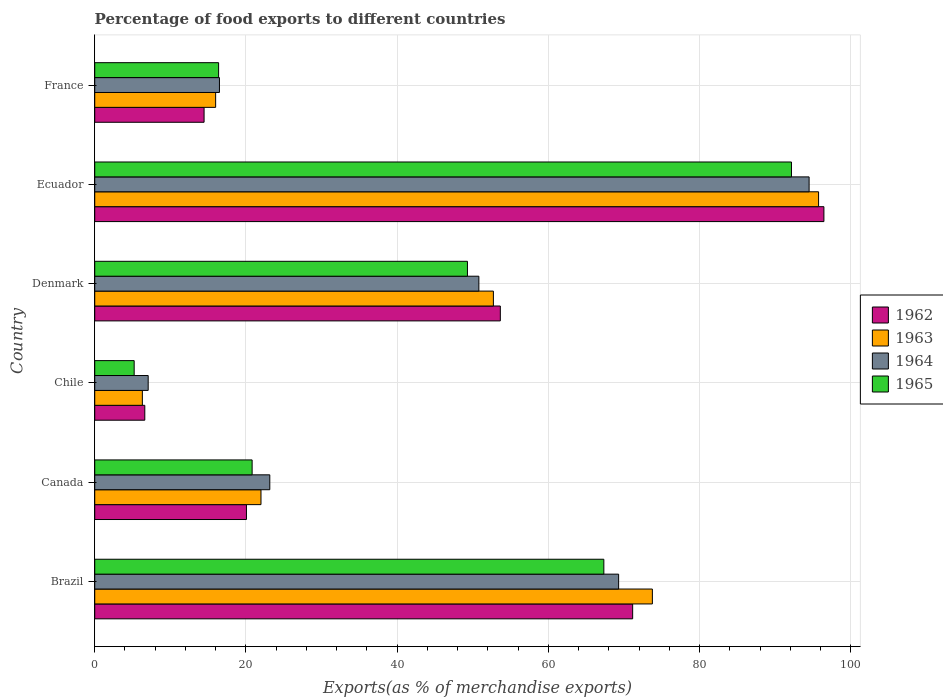How many different coloured bars are there?
Provide a short and direct response. 4. How many groups of bars are there?
Make the answer very short. 6. In how many cases, is the number of bars for a given country not equal to the number of legend labels?
Your answer should be very brief. 0. What is the percentage of exports to different countries in 1962 in Ecuador?
Ensure brevity in your answer.  96.45. Across all countries, what is the maximum percentage of exports to different countries in 1965?
Your answer should be compact. 92.15. Across all countries, what is the minimum percentage of exports to different countries in 1964?
Offer a terse response. 7.07. In which country was the percentage of exports to different countries in 1963 maximum?
Your response must be concise. Ecuador. In which country was the percentage of exports to different countries in 1965 minimum?
Offer a very short reply. Chile. What is the total percentage of exports to different countries in 1964 in the graph?
Provide a succinct answer. 261.31. What is the difference between the percentage of exports to different countries in 1962 in Canada and that in Denmark?
Provide a succinct answer. -33.58. What is the difference between the percentage of exports to different countries in 1965 in Brazil and the percentage of exports to different countries in 1963 in Denmark?
Provide a succinct answer. 14.61. What is the average percentage of exports to different countries in 1962 per country?
Provide a short and direct response. 43.73. What is the difference between the percentage of exports to different countries in 1965 and percentage of exports to different countries in 1964 in France?
Your response must be concise. -0.11. In how many countries, is the percentage of exports to different countries in 1965 greater than 36 %?
Make the answer very short. 3. What is the ratio of the percentage of exports to different countries in 1965 in Canada to that in Ecuador?
Ensure brevity in your answer.  0.23. Is the difference between the percentage of exports to different countries in 1965 in Chile and Denmark greater than the difference between the percentage of exports to different countries in 1964 in Chile and Denmark?
Provide a short and direct response. No. What is the difference between the highest and the second highest percentage of exports to different countries in 1962?
Offer a very short reply. 25.3. What is the difference between the highest and the lowest percentage of exports to different countries in 1965?
Your answer should be very brief. 86.94. In how many countries, is the percentage of exports to different countries in 1965 greater than the average percentage of exports to different countries in 1965 taken over all countries?
Your answer should be compact. 3. Is the sum of the percentage of exports to different countries in 1964 in Chile and France greater than the maximum percentage of exports to different countries in 1962 across all countries?
Keep it short and to the point. No. Is it the case that in every country, the sum of the percentage of exports to different countries in 1965 and percentage of exports to different countries in 1962 is greater than the sum of percentage of exports to different countries in 1964 and percentage of exports to different countries in 1963?
Your response must be concise. No. What does the 1st bar from the top in France represents?
Give a very brief answer. 1965. What does the 2nd bar from the bottom in Denmark represents?
Offer a terse response. 1963. Is it the case that in every country, the sum of the percentage of exports to different countries in 1963 and percentage of exports to different countries in 1964 is greater than the percentage of exports to different countries in 1965?
Give a very brief answer. Yes. How many bars are there?
Keep it short and to the point. 24. Are all the bars in the graph horizontal?
Offer a very short reply. Yes. How many countries are there in the graph?
Ensure brevity in your answer.  6. Are the values on the major ticks of X-axis written in scientific E-notation?
Ensure brevity in your answer.  No. Does the graph contain grids?
Keep it short and to the point. Yes. How many legend labels are there?
Your answer should be very brief. 4. What is the title of the graph?
Your answer should be compact. Percentage of food exports to different countries. What is the label or title of the X-axis?
Offer a terse response. Exports(as % of merchandise exports). What is the label or title of the Y-axis?
Keep it short and to the point. Country. What is the Exports(as % of merchandise exports) in 1962 in Brazil?
Provide a short and direct response. 71.15. What is the Exports(as % of merchandise exports) of 1963 in Brazil?
Give a very brief answer. 73.76. What is the Exports(as % of merchandise exports) in 1964 in Brazil?
Your answer should be compact. 69.29. What is the Exports(as % of merchandise exports) in 1965 in Brazil?
Ensure brevity in your answer.  67.34. What is the Exports(as % of merchandise exports) of 1962 in Canada?
Keep it short and to the point. 20.07. What is the Exports(as % of merchandise exports) of 1963 in Canada?
Keep it short and to the point. 21.99. What is the Exports(as % of merchandise exports) of 1964 in Canada?
Provide a short and direct response. 23.16. What is the Exports(as % of merchandise exports) in 1965 in Canada?
Your response must be concise. 20.82. What is the Exports(as % of merchandise exports) in 1962 in Chile?
Offer a very short reply. 6.62. What is the Exports(as % of merchandise exports) of 1963 in Chile?
Keep it short and to the point. 6.3. What is the Exports(as % of merchandise exports) in 1964 in Chile?
Your answer should be compact. 7.07. What is the Exports(as % of merchandise exports) in 1965 in Chile?
Your answer should be compact. 5.22. What is the Exports(as % of merchandise exports) in 1962 in Denmark?
Your answer should be very brief. 53.65. What is the Exports(as % of merchandise exports) in 1963 in Denmark?
Keep it short and to the point. 52.73. What is the Exports(as % of merchandise exports) of 1964 in Denmark?
Keep it short and to the point. 50.81. What is the Exports(as % of merchandise exports) in 1965 in Denmark?
Make the answer very short. 49.3. What is the Exports(as % of merchandise exports) of 1962 in Ecuador?
Keep it short and to the point. 96.45. What is the Exports(as % of merchandise exports) of 1963 in Ecuador?
Give a very brief answer. 95.74. What is the Exports(as % of merchandise exports) of 1964 in Ecuador?
Your answer should be very brief. 94.49. What is the Exports(as % of merchandise exports) in 1965 in Ecuador?
Keep it short and to the point. 92.15. What is the Exports(as % of merchandise exports) of 1962 in France?
Offer a very short reply. 14.46. What is the Exports(as % of merchandise exports) in 1963 in France?
Provide a succinct answer. 15.99. What is the Exports(as % of merchandise exports) in 1964 in France?
Your answer should be very brief. 16.5. What is the Exports(as % of merchandise exports) of 1965 in France?
Your answer should be compact. 16.38. Across all countries, what is the maximum Exports(as % of merchandise exports) of 1962?
Offer a terse response. 96.45. Across all countries, what is the maximum Exports(as % of merchandise exports) of 1963?
Provide a succinct answer. 95.74. Across all countries, what is the maximum Exports(as % of merchandise exports) of 1964?
Offer a terse response. 94.49. Across all countries, what is the maximum Exports(as % of merchandise exports) in 1965?
Give a very brief answer. 92.15. Across all countries, what is the minimum Exports(as % of merchandise exports) in 1962?
Provide a short and direct response. 6.62. Across all countries, what is the minimum Exports(as % of merchandise exports) of 1963?
Keep it short and to the point. 6.3. Across all countries, what is the minimum Exports(as % of merchandise exports) in 1964?
Your response must be concise. 7.07. Across all countries, what is the minimum Exports(as % of merchandise exports) in 1965?
Ensure brevity in your answer.  5.22. What is the total Exports(as % of merchandise exports) in 1962 in the graph?
Keep it short and to the point. 262.39. What is the total Exports(as % of merchandise exports) of 1963 in the graph?
Offer a very short reply. 266.51. What is the total Exports(as % of merchandise exports) of 1964 in the graph?
Your response must be concise. 261.31. What is the total Exports(as % of merchandise exports) in 1965 in the graph?
Make the answer very short. 251.21. What is the difference between the Exports(as % of merchandise exports) in 1962 in Brazil and that in Canada?
Your answer should be very brief. 51.08. What is the difference between the Exports(as % of merchandise exports) of 1963 in Brazil and that in Canada?
Ensure brevity in your answer.  51.77. What is the difference between the Exports(as % of merchandise exports) in 1964 in Brazil and that in Canada?
Your response must be concise. 46.14. What is the difference between the Exports(as % of merchandise exports) in 1965 in Brazil and that in Canada?
Offer a terse response. 46.52. What is the difference between the Exports(as % of merchandise exports) of 1962 in Brazil and that in Chile?
Make the answer very short. 64.53. What is the difference between the Exports(as % of merchandise exports) of 1963 in Brazil and that in Chile?
Make the answer very short. 67.46. What is the difference between the Exports(as % of merchandise exports) in 1964 in Brazil and that in Chile?
Give a very brief answer. 62.22. What is the difference between the Exports(as % of merchandise exports) of 1965 in Brazil and that in Chile?
Provide a succinct answer. 62.12. What is the difference between the Exports(as % of merchandise exports) in 1962 in Brazil and that in Denmark?
Your answer should be compact. 17.5. What is the difference between the Exports(as % of merchandise exports) in 1963 in Brazil and that in Denmark?
Offer a terse response. 21.03. What is the difference between the Exports(as % of merchandise exports) in 1964 in Brazil and that in Denmark?
Offer a terse response. 18.49. What is the difference between the Exports(as % of merchandise exports) in 1965 in Brazil and that in Denmark?
Your answer should be very brief. 18.04. What is the difference between the Exports(as % of merchandise exports) of 1962 in Brazil and that in Ecuador?
Provide a succinct answer. -25.3. What is the difference between the Exports(as % of merchandise exports) of 1963 in Brazil and that in Ecuador?
Your answer should be compact. -21.98. What is the difference between the Exports(as % of merchandise exports) in 1964 in Brazil and that in Ecuador?
Your response must be concise. -25.19. What is the difference between the Exports(as % of merchandise exports) in 1965 in Brazil and that in Ecuador?
Offer a very short reply. -24.82. What is the difference between the Exports(as % of merchandise exports) of 1962 in Brazil and that in France?
Offer a terse response. 56.69. What is the difference between the Exports(as % of merchandise exports) in 1963 in Brazil and that in France?
Provide a succinct answer. 57.76. What is the difference between the Exports(as % of merchandise exports) of 1964 in Brazil and that in France?
Your answer should be compact. 52.8. What is the difference between the Exports(as % of merchandise exports) in 1965 in Brazil and that in France?
Provide a short and direct response. 50.95. What is the difference between the Exports(as % of merchandise exports) of 1962 in Canada and that in Chile?
Offer a very short reply. 13.45. What is the difference between the Exports(as % of merchandise exports) in 1963 in Canada and that in Chile?
Give a very brief answer. 15.69. What is the difference between the Exports(as % of merchandise exports) of 1964 in Canada and that in Chile?
Your answer should be compact. 16.09. What is the difference between the Exports(as % of merchandise exports) of 1965 in Canada and that in Chile?
Give a very brief answer. 15.6. What is the difference between the Exports(as % of merchandise exports) in 1962 in Canada and that in Denmark?
Keep it short and to the point. -33.58. What is the difference between the Exports(as % of merchandise exports) in 1963 in Canada and that in Denmark?
Provide a succinct answer. -30.74. What is the difference between the Exports(as % of merchandise exports) in 1964 in Canada and that in Denmark?
Ensure brevity in your answer.  -27.65. What is the difference between the Exports(as % of merchandise exports) in 1965 in Canada and that in Denmark?
Provide a succinct answer. -28.48. What is the difference between the Exports(as % of merchandise exports) of 1962 in Canada and that in Ecuador?
Your response must be concise. -76.38. What is the difference between the Exports(as % of merchandise exports) in 1963 in Canada and that in Ecuador?
Offer a very short reply. -73.75. What is the difference between the Exports(as % of merchandise exports) in 1964 in Canada and that in Ecuador?
Give a very brief answer. -71.33. What is the difference between the Exports(as % of merchandise exports) of 1965 in Canada and that in Ecuador?
Offer a terse response. -71.34. What is the difference between the Exports(as % of merchandise exports) of 1962 in Canada and that in France?
Make the answer very short. 5.6. What is the difference between the Exports(as % of merchandise exports) in 1963 in Canada and that in France?
Make the answer very short. 6. What is the difference between the Exports(as % of merchandise exports) of 1964 in Canada and that in France?
Provide a succinct answer. 6.66. What is the difference between the Exports(as % of merchandise exports) of 1965 in Canada and that in France?
Provide a short and direct response. 4.43. What is the difference between the Exports(as % of merchandise exports) in 1962 in Chile and that in Denmark?
Provide a succinct answer. -47.02. What is the difference between the Exports(as % of merchandise exports) of 1963 in Chile and that in Denmark?
Offer a terse response. -46.43. What is the difference between the Exports(as % of merchandise exports) of 1964 in Chile and that in Denmark?
Offer a terse response. -43.74. What is the difference between the Exports(as % of merchandise exports) of 1965 in Chile and that in Denmark?
Offer a terse response. -44.08. What is the difference between the Exports(as % of merchandise exports) in 1962 in Chile and that in Ecuador?
Your answer should be compact. -89.82. What is the difference between the Exports(as % of merchandise exports) in 1963 in Chile and that in Ecuador?
Offer a terse response. -89.44. What is the difference between the Exports(as % of merchandise exports) of 1964 in Chile and that in Ecuador?
Make the answer very short. -87.42. What is the difference between the Exports(as % of merchandise exports) of 1965 in Chile and that in Ecuador?
Make the answer very short. -86.94. What is the difference between the Exports(as % of merchandise exports) in 1962 in Chile and that in France?
Your answer should be compact. -7.84. What is the difference between the Exports(as % of merchandise exports) of 1963 in Chile and that in France?
Make the answer very short. -9.69. What is the difference between the Exports(as % of merchandise exports) of 1964 in Chile and that in France?
Keep it short and to the point. -9.43. What is the difference between the Exports(as % of merchandise exports) in 1965 in Chile and that in France?
Your response must be concise. -11.17. What is the difference between the Exports(as % of merchandise exports) in 1962 in Denmark and that in Ecuador?
Ensure brevity in your answer.  -42.8. What is the difference between the Exports(as % of merchandise exports) in 1963 in Denmark and that in Ecuador?
Make the answer very short. -43.01. What is the difference between the Exports(as % of merchandise exports) in 1964 in Denmark and that in Ecuador?
Your answer should be compact. -43.68. What is the difference between the Exports(as % of merchandise exports) in 1965 in Denmark and that in Ecuador?
Give a very brief answer. -42.86. What is the difference between the Exports(as % of merchandise exports) in 1962 in Denmark and that in France?
Offer a terse response. 39.18. What is the difference between the Exports(as % of merchandise exports) in 1963 in Denmark and that in France?
Your response must be concise. 36.74. What is the difference between the Exports(as % of merchandise exports) in 1964 in Denmark and that in France?
Keep it short and to the point. 34.31. What is the difference between the Exports(as % of merchandise exports) of 1965 in Denmark and that in France?
Your answer should be compact. 32.91. What is the difference between the Exports(as % of merchandise exports) of 1962 in Ecuador and that in France?
Offer a very short reply. 81.98. What is the difference between the Exports(as % of merchandise exports) in 1963 in Ecuador and that in France?
Make the answer very short. 79.75. What is the difference between the Exports(as % of merchandise exports) of 1964 in Ecuador and that in France?
Your response must be concise. 77.99. What is the difference between the Exports(as % of merchandise exports) of 1965 in Ecuador and that in France?
Your response must be concise. 75.77. What is the difference between the Exports(as % of merchandise exports) of 1962 in Brazil and the Exports(as % of merchandise exports) of 1963 in Canada?
Your answer should be compact. 49.16. What is the difference between the Exports(as % of merchandise exports) of 1962 in Brazil and the Exports(as % of merchandise exports) of 1964 in Canada?
Keep it short and to the point. 47.99. What is the difference between the Exports(as % of merchandise exports) in 1962 in Brazil and the Exports(as % of merchandise exports) in 1965 in Canada?
Provide a short and direct response. 50.33. What is the difference between the Exports(as % of merchandise exports) of 1963 in Brazil and the Exports(as % of merchandise exports) of 1964 in Canada?
Make the answer very short. 50.6. What is the difference between the Exports(as % of merchandise exports) in 1963 in Brazil and the Exports(as % of merchandise exports) in 1965 in Canada?
Ensure brevity in your answer.  52.94. What is the difference between the Exports(as % of merchandise exports) of 1964 in Brazil and the Exports(as % of merchandise exports) of 1965 in Canada?
Your answer should be very brief. 48.48. What is the difference between the Exports(as % of merchandise exports) in 1962 in Brazil and the Exports(as % of merchandise exports) in 1963 in Chile?
Provide a succinct answer. 64.85. What is the difference between the Exports(as % of merchandise exports) in 1962 in Brazil and the Exports(as % of merchandise exports) in 1964 in Chile?
Make the answer very short. 64.08. What is the difference between the Exports(as % of merchandise exports) in 1962 in Brazil and the Exports(as % of merchandise exports) in 1965 in Chile?
Provide a succinct answer. 65.93. What is the difference between the Exports(as % of merchandise exports) of 1963 in Brazil and the Exports(as % of merchandise exports) of 1964 in Chile?
Offer a very short reply. 66.69. What is the difference between the Exports(as % of merchandise exports) of 1963 in Brazil and the Exports(as % of merchandise exports) of 1965 in Chile?
Your answer should be very brief. 68.54. What is the difference between the Exports(as % of merchandise exports) of 1964 in Brazil and the Exports(as % of merchandise exports) of 1965 in Chile?
Offer a terse response. 64.08. What is the difference between the Exports(as % of merchandise exports) in 1962 in Brazil and the Exports(as % of merchandise exports) in 1963 in Denmark?
Your response must be concise. 18.42. What is the difference between the Exports(as % of merchandise exports) of 1962 in Brazil and the Exports(as % of merchandise exports) of 1964 in Denmark?
Offer a terse response. 20.34. What is the difference between the Exports(as % of merchandise exports) in 1962 in Brazil and the Exports(as % of merchandise exports) in 1965 in Denmark?
Offer a terse response. 21.85. What is the difference between the Exports(as % of merchandise exports) in 1963 in Brazil and the Exports(as % of merchandise exports) in 1964 in Denmark?
Make the answer very short. 22.95. What is the difference between the Exports(as % of merchandise exports) of 1963 in Brazil and the Exports(as % of merchandise exports) of 1965 in Denmark?
Your answer should be compact. 24.46. What is the difference between the Exports(as % of merchandise exports) of 1964 in Brazil and the Exports(as % of merchandise exports) of 1965 in Denmark?
Your answer should be very brief. 20. What is the difference between the Exports(as % of merchandise exports) in 1962 in Brazil and the Exports(as % of merchandise exports) in 1963 in Ecuador?
Your answer should be very brief. -24.59. What is the difference between the Exports(as % of merchandise exports) of 1962 in Brazil and the Exports(as % of merchandise exports) of 1964 in Ecuador?
Ensure brevity in your answer.  -23.34. What is the difference between the Exports(as % of merchandise exports) of 1962 in Brazil and the Exports(as % of merchandise exports) of 1965 in Ecuador?
Your response must be concise. -21.01. What is the difference between the Exports(as % of merchandise exports) in 1963 in Brazil and the Exports(as % of merchandise exports) in 1964 in Ecuador?
Give a very brief answer. -20.73. What is the difference between the Exports(as % of merchandise exports) in 1963 in Brazil and the Exports(as % of merchandise exports) in 1965 in Ecuador?
Offer a terse response. -18.4. What is the difference between the Exports(as % of merchandise exports) in 1964 in Brazil and the Exports(as % of merchandise exports) in 1965 in Ecuador?
Ensure brevity in your answer.  -22.86. What is the difference between the Exports(as % of merchandise exports) of 1962 in Brazil and the Exports(as % of merchandise exports) of 1963 in France?
Offer a terse response. 55.16. What is the difference between the Exports(as % of merchandise exports) of 1962 in Brazil and the Exports(as % of merchandise exports) of 1964 in France?
Keep it short and to the point. 54.65. What is the difference between the Exports(as % of merchandise exports) in 1962 in Brazil and the Exports(as % of merchandise exports) in 1965 in France?
Your answer should be very brief. 54.77. What is the difference between the Exports(as % of merchandise exports) of 1963 in Brazil and the Exports(as % of merchandise exports) of 1964 in France?
Provide a short and direct response. 57.26. What is the difference between the Exports(as % of merchandise exports) of 1963 in Brazil and the Exports(as % of merchandise exports) of 1965 in France?
Ensure brevity in your answer.  57.37. What is the difference between the Exports(as % of merchandise exports) of 1964 in Brazil and the Exports(as % of merchandise exports) of 1965 in France?
Provide a short and direct response. 52.91. What is the difference between the Exports(as % of merchandise exports) in 1962 in Canada and the Exports(as % of merchandise exports) in 1963 in Chile?
Provide a succinct answer. 13.77. What is the difference between the Exports(as % of merchandise exports) in 1962 in Canada and the Exports(as % of merchandise exports) in 1964 in Chile?
Ensure brevity in your answer.  13. What is the difference between the Exports(as % of merchandise exports) in 1962 in Canada and the Exports(as % of merchandise exports) in 1965 in Chile?
Your answer should be very brief. 14.85. What is the difference between the Exports(as % of merchandise exports) of 1963 in Canada and the Exports(as % of merchandise exports) of 1964 in Chile?
Provide a short and direct response. 14.92. What is the difference between the Exports(as % of merchandise exports) in 1963 in Canada and the Exports(as % of merchandise exports) in 1965 in Chile?
Make the answer very short. 16.77. What is the difference between the Exports(as % of merchandise exports) of 1964 in Canada and the Exports(as % of merchandise exports) of 1965 in Chile?
Ensure brevity in your answer.  17.94. What is the difference between the Exports(as % of merchandise exports) of 1962 in Canada and the Exports(as % of merchandise exports) of 1963 in Denmark?
Keep it short and to the point. -32.66. What is the difference between the Exports(as % of merchandise exports) in 1962 in Canada and the Exports(as % of merchandise exports) in 1964 in Denmark?
Provide a short and direct response. -30.74. What is the difference between the Exports(as % of merchandise exports) in 1962 in Canada and the Exports(as % of merchandise exports) in 1965 in Denmark?
Make the answer very short. -29.23. What is the difference between the Exports(as % of merchandise exports) in 1963 in Canada and the Exports(as % of merchandise exports) in 1964 in Denmark?
Provide a succinct answer. -28.82. What is the difference between the Exports(as % of merchandise exports) in 1963 in Canada and the Exports(as % of merchandise exports) in 1965 in Denmark?
Your answer should be compact. -27.31. What is the difference between the Exports(as % of merchandise exports) in 1964 in Canada and the Exports(as % of merchandise exports) in 1965 in Denmark?
Provide a succinct answer. -26.14. What is the difference between the Exports(as % of merchandise exports) in 1962 in Canada and the Exports(as % of merchandise exports) in 1963 in Ecuador?
Your answer should be compact. -75.67. What is the difference between the Exports(as % of merchandise exports) in 1962 in Canada and the Exports(as % of merchandise exports) in 1964 in Ecuador?
Make the answer very short. -74.42. What is the difference between the Exports(as % of merchandise exports) in 1962 in Canada and the Exports(as % of merchandise exports) in 1965 in Ecuador?
Make the answer very short. -72.09. What is the difference between the Exports(as % of merchandise exports) in 1963 in Canada and the Exports(as % of merchandise exports) in 1964 in Ecuador?
Your response must be concise. -72.5. What is the difference between the Exports(as % of merchandise exports) in 1963 in Canada and the Exports(as % of merchandise exports) in 1965 in Ecuador?
Provide a succinct answer. -70.16. What is the difference between the Exports(as % of merchandise exports) in 1964 in Canada and the Exports(as % of merchandise exports) in 1965 in Ecuador?
Your answer should be compact. -69. What is the difference between the Exports(as % of merchandise exports) in 1962 in Canada and the Exports(as % of merchandise exports) in 1963 in France?
Keep it short and to the point. 4.07. What is the difference between the Exports(as % of merchandise exports) of 1962 in Canada and the Exports(as % of merchandise exports) of 1964 in France?
Give a very brief answer. 3.57. What is the difference between the Exports(as % of merchandise exports) of 1962 in Canada and the Exports(as % of merchandise exports) of 1965 in France?
Give a very brief answer. 3.68. What is the difference between the Exports(as % of merchandise exports) in 1963 in Canada and the Exports(as % of merchandise exports) in 1964 in France?
Make the answer very short. 5.49. What is the difference between the Exports(as % of merchandise exports) in 1963 in Canada and the Exports(as % of merchandise exports) in 1965 in France?
Make the answer very short. 5.61. What is the difference between the Exports(as % of merchandise exports) in 1964 in Canada and the Exports(as % of merchandise exports) in 1965 in France?
Your answer should be very brief. 6.77. What is the difference between the Exports(as % of merchandise exports) in 1962 in Chile and the Exports(as % of merchandise exports) in 1963 in Denmark?
Offer a very short reply. -46.11. What is the difference between the Exports(as % of merchandise exports) in 1962 in Chile and the Exports(as % of merchandise exports) in 1964 in Denmark?
Keep it short and to the point. -44.19. What is the difference between the Exports(as % of merchandise exports) of 1962 in Chile and the Exports(as % of merchandise exports) of 1965 in Denmark?
Your answer should be very brief. -42.68. What is the difference between the Exports(as % of merchandise exports) in 1963 in Chile and the Exports(as % of merchandise exports) in 1964 in Denmark?
Make the answer very short. -44.51. What is the difference between the Exports(as % of merchandise exports) in 1963 in Chile and the Exports(as % of merchandise exports) in 1965 in Denmark?
Give a very brief answer. -43. What is the difference between the Exports(as % of merchandise exports) in 1964 in Chile and the Exports(as % of merchandise exports) in 1965 in Denmark?
Keep it short and to the point. -42.23. What is the difference between the Exports(as % of merchandise exports) of 1962 in Chile and the Exports(as % of merchandise exports) of 1963 in Ecuador?
Your answer should be compact. -89.12. What is the difference between the Exports(as % of merchandise exports) of 1962 in Chile and the Exports(as % of merchandise exports) of 1964 in Ecuador?
Your answer should be very brief. -87.87. What is the difference between the Exports(as % of merchandise exports) in 1962 in Chile and the Exports(as % of merchandise exports) in 1965 in Ecuador?
Give a very brief answer. -85.53. What is the difference between the Exports(as % of merchandise exports) in 1963 in Chile and the Exports(as % of merchandise exports) in 1964 in Ecuador?
Provide a short and direct response. -88.19. What is the difference between the Exports(as % of merchandise exports) in 1963 in Chile and the Exports(as % of merchandise exports) in 1965 in Ecuador?
Provide a succinct answer. -85.86. What is the difference between the Exports(as % of merchandise exports) of 1964 in Chile and the Exports(as % of merchandise exports) of 1965 in Ecuador?
Offer a very short reply. -85.08. What is the difference between the Exports(as % of merchandise exports) of 1962 in Chile and the Exports(as % of merchandise exports) of 1963 in France?
Your response must be concise. -9.37. What is the difference between the Exports(as % of merchandise exports) in 1962 in Chile and the Exports(as % of merchandise exports) in 1964 in France?
Offer a very short reply. -9.87. What is the difference between the Exports(as % of merchandise exports) of 1962 in Chile and the Exports(as % of merchandise exports) of 1965 in France?
Give a very brief answer. -9.76. What is the difference between the Exports(as % of merchandise exports) in 1963 in Chile and the Exports(as % of merchandise exports) in 1964 in France?
Make the answer very short. -10.2. What is the difference between the Exports(as % of merchandise exports) of 1963 in Chile and the Exports(as % of merchandise exports) of 1965 in France?
Keep it short and to the point. -10.09. What is the difference between the Exports(as % of merchandise exports) in 1964 in Chile and the Exports(as % of merchandise exports) in 1965 in France?
Your response must be concise. -9.31. What is the difference between the Exports(as % of merchandise exports) of 1962 in Denmark and the Exports(as % of merchandise exports) of 1963 in Ecuador?
Your answer should be compact. -42.09. What is the difference between the Exports(as % of merchandise exports) in 1962 in Denmark and the Exports(as % of merchandise exports) in 1964 in Ecuador?
Make the answer very short. -40.84. What is the difference between the Exports(as % of merchandise exports) of 1962 in Denmark and the Exports(as % of merchandise exports) of 1965 in Ecuador?
Your response must be concise. -38.51. What is the difference between the Exports(as % of merchandise exports) in 1963 in Denmark and the Exports(as % of merchandise exports) in 1964 in Ecuador?
Keep it short and to the point. -41.76. What is the difference between the Exports(as % of merchandise exports) in 1963 in Denmark and the Exports(as % of merchandise exports) in 1965 in Ecuador?
Give a very brief answer. -39.43. What is the difference between the Exports(as % of merchandise exports) of 1964 in Denmark and the Exports(as % of merchandise exports) of 1965 in Ecuador?
Offer a terse response. -41.35. What is the difference between the Exports(as % of merchandise exports) in 1962 in Denmark and the Exports(as % of merchandise exports) in 1963 in France?
Ensure brevity in your answer.  37.65. What is the difference between the Exports(as % of merchandise exports) of 1962 in Denmark and the Exports(as % of merchandise exports) of 1964 in France?
Make the answer very short. 37.15. What is the difference between the Exports(as % of merchandise exports) of 1962 in Denmark and the Exports(as % of merchandise exports) of 1965 in France?
Keep it short and to the point. 37.26. What is the difference between the Exports(as % of merchandise exports) of 1963 in Denmark and the Exports(as % of merchandise exports) of 1964 in France?
Your answer should be compact. 36.23. What is the difference between the Exports(as % of merchandise exports) of 1963 in Denmark and the Exports(as % of merchandise exports) of 1965 in France?
Make the answer very short. 36.34. What is the difference between the Exports(as % of merchandise exports) of 1964 in Denmark and the Exports(as % of merchandise exports) of 1965 in France?
Offer a terse response. 34.42. What is the difference between the Exports(as % of merchandise exports) of 1962 in Ecuador and the Exports(as % of merchandise exports) of 1963 in France?
Your answer should be very brief. 80.45. What is the difference between the Exports(as % of merchandise exports) of 1962 in Ecuador and the Exports(as % of merchandise exports) of 1964 in France?
Your answer should be very brief. 79.95. What is the difference between the Exports(as % of merchandise exports) of 1962 in Ecuador and the Exports(as % of merchandise exports) of 1965 in France?
Your answer should be compact. 80.06. What is the difference between the Exports(as % of merchandise exports) of 1963 in Ecuador and the Exports(as % of merchandise exports) of 1964 in France?
Keep it short and to the point. 79.24. What is the difference between the Exports(as % of merchandise exports) of 1963 in Ecuador and the Exports(as % of merchandise exports) of 1965 in France?
Offer a very short reply. 79.36. What is the difference between the Exports(as % of merchandise exports) in 1964 in Ecuador and the Exports(as % of merchandise exports) in 1965 in France?
Your response must be concise. 78.1. What is the average Exports(as % of merchandise exports) in 1962 per country?
Your answer should be very brief. 43.73. What is the average Exports(as % of merchandise exports) of 1963 per country?
Ensure brevity in your answer.  44.42. What is the average Exports(as % of merchandise exports) in 1964 per country?
Ensure brevity in your answer.  43.55. What is the average Exports(as % of merchandise exports) in 1965 per country?
Give a very brief answer. 41.87. What is the difference between the Exports(as % of merchandise exports) of 1962 and Exports(as % of merchandise exports) of 1963 in Brazil?
Provide a succinct answer. -2.61. What is the difference between the Exports(as % of merchandise exports) of 1962 and Exports(as % of merchandise exports) of 1964 in Brazil?
Provide a short and direct response. 1.86. What is the difference between the Exports(as % of merchandise exports) in 1962 and Exports(as % of merchandise exports) in 1965 in Brazil?
Offer a very short reply. 3.81. What is the difference between the Exports(as % of merchandise exports) of 1963 and Exports(as % of merchandise exports) of 1964 in Brazil?
Your answer should be very brief. 4.46. What is the difference between the Exports(as % of merchandise exports) in 1963 and Exports(as % of merchandise exports) in 1965 in Brazil?
Make the answer very short. 6.42. What is the difference between the Exports(as % of merchandise exports) of 1964 and Exports(as % of merchandise exports) of 1965 in Brazil?
Provide a succinct answer. 1.96. What is the difference between the Exports(as % of merchandise exports) in 1962 and Exports(as % of merchandise exports) in 1963 in Canada?
Ensure brevity in your answer.  -1.92. What is the difference between the Exports(as % of merchandise exports) of 1962 and Exports(as % of merchandise exports) of 1964 in Canada?
Give a very brief answer. -3.09. What is the difference between the Exports(as % of merchandise exports) of 1962 and Exports(as % of merchandise exports) of 1965 in Canada?
Provide a succinct answer. -0.75. What is the difference between the Exports(as % of merchandise exports) in 1963 and Exports(as % of merchandise exports) in 1964 in Canada?
Make the answer very short. -1.17. What is the difference between the Exports(as % of merchandise exports) of 1963 and Exports(as % of merchandise exports) of 1965 in Canada?
Your answer should be compact. 1.17. What is the difference between the Exports(as % of merchandise exports) of 1964 and Exports(as % of merchandise exports) of 1965 in Canada?
Keep it short and to the point. 2.34. What is the difference between the Exports(as % of merchandise exports) in 1962 and Exports(as % of merchandise exports) in 1963 in Chile?
Ensure brevity in your answer.  0.32. What is the difference between the Exports(as % of merchandise exports) in 1962 and Exports(as % of merchandise exports) in 1964 in Chile?
Provide a succinct answer. -0.45. What is the difference between the Exports(as % of merchandise exports) of 1962 and Exports(as % of merchandise exports) of 1965 in Chile?
Give a very brief answer. 1.4. What is the difference between the Exports(as % of merchandise exports) of 1963 and Exports(as % of merchandise exports) of 1964 in Chile?
Your answer should be compact. -0.77. What is the difference between the Exports(as % of merchandise exports) of 1963 and Exports(as % of merchandise exports) of 1965 in Chile?
Ensure brevity in your answer.  1.08. What is the difference between the Exports(as % of merchandise exports) of 1964 and Exports(as % of merchandise exports) of 1965 in Chile?
Provide a succinct answer. 1.85. What is the difference between the Exports(as % of merchandise exports) of 1962 and Exports(as % of merchandise exports) of 1963 in Denmark?
Keep it short and to the point. 0.92. What is the difference between the Exports(as % of merchandise exports) of 1962 and Exports(as % of merchandise exports) of 1964 in Denmark?
Give a very brief answer. 2.84. What is the difference between the Exports(as % of merchandise exports) in 1962 and Exports(as % of merchandise exports) in 1965 in Denmark?
Offer a very short reply. 4.35. What is the difference between the Exports(as % of merchandise exports) in 1963 and Exports(as % of merchandise exports) in 1964 in Denmark?
Provide a short and direct response. 1.92. What is the difference between the Exports(as % of merchandise exports) of 1963 and Exports(as % of merchandise exports) of 1965 in Denmark?
Your answer should be very brief. 3.43. What is the difference between the Exports(as % of merchandise exports) of 1964 and Exports(as % of merchandise exports) of 1965 in Denmark?
Your answer should be very brief. 1.51. What is the difference between the Exports(as % of merchandise exports) in 1962 and Exports(as % of merchandise exports) in 1963 in Ecuador?
Ensure brevity in your answer.  0.71. What is the difference between the Exports(as % of merchandise exports) of 1962 and Exports(as % of merchandise exports) of 1964 in Ecuador?
Offer a terse response. 1.96. What is the difference between the Exports(as % of merchandise exports) in 1962 and Exports(as % of merchandise exports) in 1965 in Ecuador?
Offer a very short reply. 4.29. What is the difference between the Exports(as % of merchandise exports) of 1963 and Exports(as % of merchandise exports) of 1964 in Ecuador?
Your answer should be very brief. 1.25. What is the difference between the Exports(as % of merchandise exports) in 1963 and Exports(as % of merchandise exports) in 1965 in Ecuador?
Ensure brevity in your answer.  3.58. What is the difference between the Exports(as % of merchandise exports) of 1964 and Exports(as % of merchandise exports) of 1965 in Ecuador?
Ensure brevity in your answer.  2.33. What is the difference between the Exports(as % of merchandise exports) in 1962 and Exports(as % of merchandise exports) in 1963 in France?
Ensure brevity in your answer.  -1.53. What is the difference between the Exports(as % of merchandise exports) in 1962 and Exports(as % of merchandise exports) in 1964 in France?
Keep it short and to the point. -2.03. What is the difference between the Exports(as % of merchandise exports) of 1962 and Exports(as % of merchandise exports) of 1965 in France?
Give a very brief answer. -1.92. What is the difference between the Exports(as % of merchandise exports) of 1963 and Exports(as % of merchandise exports) of 1964 in France?
Provide a short and direct response. -0.5. What is the difference between the Exports(as % of merchandise exports) of 1963 and Exports(as % of merchandise exports) of 1965 in France?
Keep it short and to the point. -0.39. What is the difference between the Exports(as % of merchandise exports) in 1964 and Exports(as % of merchandise exports) in 1965 in France?
Ensure brevity in your answer.  0.11. What is the ratio of the Exports(as % of merchandise exports) of 1962 in Brazil to that in Canada?
Provide a short and direct response. 3.55. What is the ratio of the Exports(as % of merchandise exports) in 1963 in Brazil to that in Canada?
Your answer should be compact. 3.35. What is the ratio of the Exports(as % of merchandise exports) in 1964 in Brazil to that in Canada?
Make the answer very short. 2.99. What is the ratio of the Exports(as % of merchandise exports) of 1965 in Brazil to that in Canada?
Your answer should be very brief. 3.23. What is the ratio of the Exports(as % of merchandise exports) in 1962 in Brazil to that in Chile?
Give a very brief answer. 10.75. What is the ratio of the Exports(as % of merchandise exports) in 1963 in Brazil to that in Chile?
Provide a succinct answer. 11.71. What is the ratio of the Exports(as % of merchandise exports) in 1964 in Brazil to that in Chile?
Your answer should be very brief. 9.8. What is the ratio of the Exports(as % of merchandise exports) in 1965 in Brazil to that in Chile?
Offer a very short reply. 12.91. What is the ratio of the Exports(as % of merchandise exports) in 1962 in Brazil to that in Denmark?
Offer a very short reply. 1.33. What is the ratio of the Exports(as % of merchandise exports) of 1963 in Brazil to that in Denmark?
Your response must be concise. 1.4. What is the ratio of the Exports(as % of merchandise exports) in 1964 in Brazil to that in Denmark?
Your answer should be very brief. 1.36. What is the ratio of the Exports(as % of merchandise exports) of 1965 in Brazil to that in Denmark?
Your answer should be compact. 1.37. What is the ratio of the Exports(as % of merchandise exports) in 1962 in Brazil to that in Ecuador?
Provide a succinct answer. 0.74. What is the ratio of the Exports(as % of merchandise exports) in 1963 in Brazil to that in Ecuador?
Make the answer very short. 0.77. What is the ratio of the Exports(as % of merchandise exports) of 1964 in Brazil to that in Ecuador?
Give a very brief answer. 0.73. What is the ratio of the Exports(as % of merchandise exports) of 1965 in Brazil to that in Ecuador?
Provide a succinct answer. 0.73. What is the ratio of the Exports(as % of merchandise exports) of 1962 in Brazil to that in France?
Your response must be concise. 4.92. What is the ratio of the Exports(as % of merchandise exports) in 1963 in Brazil to that in France?
Ensure brevity in your answer.  4.61. What is the ratio of the Exports(as % of merchandise exports) of 1964 in Brazil to that in France?
Offer a terse response. 4.2. What is the ratio of the Exports(as % of merchandise exports) of 1965 in Brazil to that in France?
Provide a short and direct response. 4.11. What is the ratio of the Exports(as % of merchandise exports) in 1962 in Canada to that in Chile?
Provide a succinct answer. 3.03. What is the ratio of the Exports(as % of merchandise exports) of 1963 in Canada to that in Chile?
Provide a short and direct response. 3.49. What is the ratio of the Exports(as % of merchandise exports) of 1964 in Canada to that in Chile?
Keep it short and to the point. 3.28. What is the ratio of the Exports(as % of merchandise exports) in 1965 in Canada to that in Chile?
Offer a very short reply. 3.99. What is the ratio of the Exports(as % of merchandise exports) in 1962 in Canada to that in Denmark?
Your response must be concise. 0.37. What is the ratio of the Exports(as % of merchandise exports) of 1963 in Canada to that in Denmark?
Offer a very short reply. 0.42. What is the ratio of the Exports(as % of merchandise exports) in 1964 in Canada to that in Denmark?
Offer a very short reply. 0.46. What is the ratio of the Exports(as % of merchandise exports) in 1965 in Canada to that in Denmark?
Ensure brevity in your answer.  0.42. What is the ratio of the Exports(as % of merchandise exports) of 1962 in Canada to that in Ecuador?
Provide a short and direct response. 0.21. What is the ratio of the Exports(as % of merchandise exports) of 1963 in Canada to that in Ecuador?
Ensure brevity in your answer.  0.23. What is the ratio of the Exports(as % of merchandise exports) in 1964 in Canada to that in Ecuador?
Your response must be concise. 0.25. What is the ratio of the Exports(as % of merchandise exports) in 1965 in Canada to that in Ecuador?
Make the answer very short. 0.23. What is the ratio of the Exports(as % of merchandise exports) in 1962 in Canada to that in France?
Your answer should be very brief. 1.39. What is the ratio of the Exports(as % of merchandise exports) in 1963 in Canada to that in France?
Make the answer very short. 1.38. What is the ratio of the Exports(as % of merchandise exports) in 1964 in Canada to that in France?
Your response must be concise. 1.4. What is the ratio of the Exports(as % of merchandise exports) of 1965 in Canada to that in France?
Give a very brief answer. 1.27. What is the ratio of the Exports(as % of merchandise exports) in 1962 in Chile to that in Denmark?
Your answer should be compact. 0.12. What is the ratio of the Exports(as % of merchandise exports) of 1963 in Chile to that in Denmark?
Keep it short and to the point. 0.12. What is the ratio of the Exports(as % of merchandise exports) in 1964 in Chile to that in Denmark?
Give a very brief answer. 0.14. What is the ratio of the Exports(as % of merchandise exports) in 1965 in Chile to that in Denmark?
Provide a succinct answer. 0.11. What is the ratio of the Exports(as % of merchandise exports) in 1962 in Chile to that in Ecuador?
Keep it short and to the point. 0.07. What is the ratio of the Exports(as % of merchandise exports) in 1963 in Chile to that in Ecuador?
Offer a very short reply. 0.07. What is the ratio of the Exports(as % of merchandise exports) of 1964 in Chile to that in Ecuador?
Give a very brief answer. 0.07. What is the ratio of the Exports(as % of merchandise exports) of 1965 in Chile to that in Ecuador?
Your response must be concise. 0.06. What is the ratio of the Exports(as % of merchandise exports) in 1962 in Chile to that in France?
Give a very brief answer. 0.46. What is the ratio of the Exports(as % of merchandise exports) in 1963 in Chile to that in France?
Ensure brevity in your answer.  0.39. What is the ratio of the Exports(as % of merchandise exports) in 1964 in Chile to that in France?
Offer a very short reply. 0.43. What is the ratio of the Exports(as % of merchandise exports) of 1965 in Chile to that in France?
Keep it short and to the point. 0.32. What is the ratio of the Exports(as % of merchandise exports) in 1962 in Denmark to that in Ecuador?
Provide a short and direct response. 0.56. What is the ratio of the Exports(as % of merchandise exports) of 1963 in Denmark to that in Ecuador?
Offer a terse response. 0.55. What is the ratio of the Exports(as % of merchandise exports) of 1964 in Denmark to that in Ecuador?
Provide a short and direct response. 0.54. What is the ratio of the Exports(as % of merchandise exports) in 1965 in Denmark to that in Ecuador?
Make the answer very short. 0.53. What is the ratio of the Exports(as % of merchandise exports) of 1962 in Denmark to that in France?
Provide a short and direct response. 3.71. What is the ratio of the Exports(as % of merchandise exports) of 1963 in Denmark to that in France?
Keep it short and to the point. 3.3. What is the ratio of the Exports(as % of merchandise exports) of 1964 in Denmark to that in France?
Make the answer very short. 3.08. What is the ratio of the Exports(as % of merchandise exports) of 1965 in Denmark to that in France?
Give a very brief answer. 3.01. What is the ratio of the Exports(as % of merchandise exports) of 1962 in Ecuador to that in France?
Your answer should be compact. 6.67. What is the ratio of the Exports(as % of merchandise exports) in 1963 in Ecuador to that in France?
Make the answer very short. 5.99. What is the ratio of the Exports(as % of merchandise exports) of 1964 in Ecuador to that in France?
Your response must be concise. 5.73. What is the ratio of the Exports(as % of merchandise exports) in 1965 in Ecuador to that in France?
Your answer should be very brief. 5.62. What is the difference between the highest and the second highest Exports(as % of merchandise exports) of 1962?
Offer a very short reply. 25.3. What is the difference between the highest and the second highest Exports(as % of merchandise exports) of 1963?
Your response must be concise. 21.98. What is the difference between the highest and the second highest Exports(as % of merchandise exports) in 1964?
Your answer should be compact. 25.19. What is the difference between the highest and the second highest Exports(as % of merchandise exports) in 1965?
Your answer should be compact. 24.82. What is the difference between the highest and the lowest Exports(as % of merchandise exports) in 1962?
Your answer should be very brief. 89.82. What is the difference between the highest and the lowest Exports(as % of merchandise exports) of 1963?
Keep it short and to the point. 89.44. What is the difference between the highest and the lowest Exports(as % of merchandise exports) in 1964?
Your answer should be very brief. 87.42. What is the difference between the highest and the lowest Exports(as % of merchandise exports) in 1965?
Offer a very short reply. 86.94. 